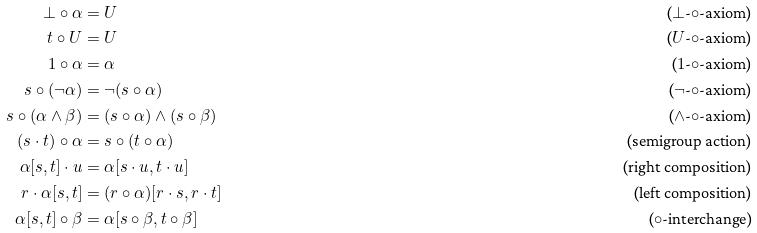Convert formula to latex. <formula><loc_0><loc_0><loc_500><loc_500>\bot \circ \alpha & = U & \text {($\bot$-$\circ$-axiom)} \\ t \circ U & = U & \text {($U$-$\circ$-axiom)} \\ 1 \circ \alpha & = \alpha & \text {($1$-$\circ$-axiom)} \\ s \circ ( \neg \alpha ) & = \neg ( s \circ \alpha ) & \text {($\neg$-$\circ$-axiom)} \\ s \circ ( \alpha \wedge \beta ) & = ( s \circ \alpha ) \wedge ( s \circ \beta ) & \text {($\wedge$-$\circ$-axiom)} \\ ( s \cdot t ) \circ \alpha & = s \circ ( t \circ \alpha ) & \text {(semigroup action)} \\ \alpha [ s , t ] \cdot u & = \alpha [ s \cdot u , t \cdot u ] & \text {(right composition)} \\ r \cdot \alpha [ s , t ] & = ( r \circ \alpha ) [ r \cdot s , r \cdot t ] & \text {(left composition)} \\ \alpha [ s , t ] \circ \beta & = \alpha [ s \circ \beta , t \circ \beta ] & \text {($\circ$-interchange)}</formula> 